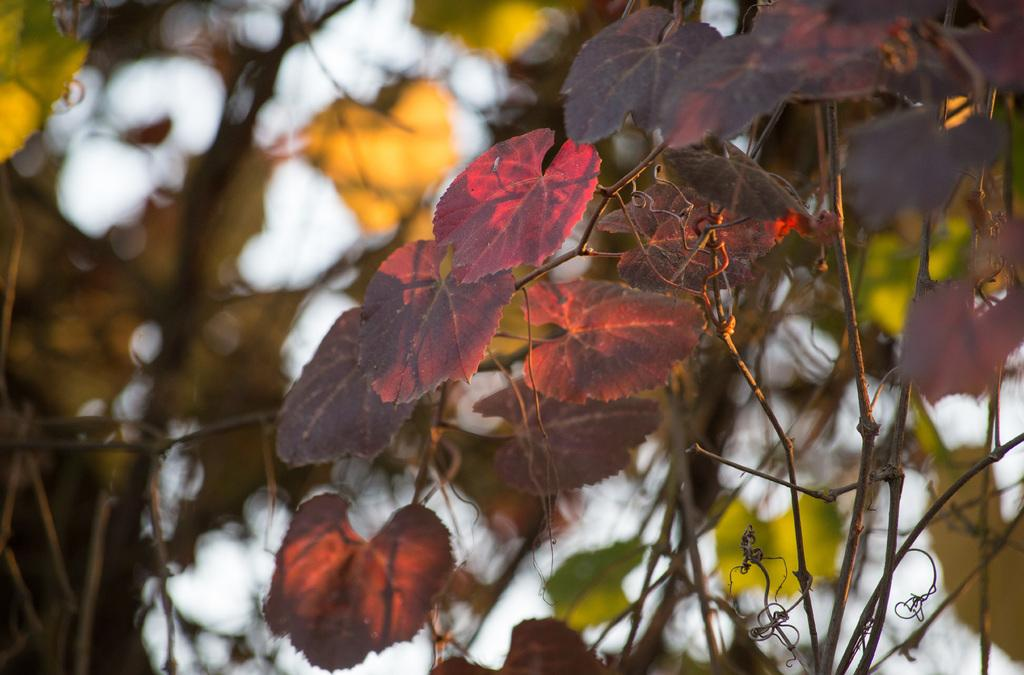What type of natural elements are present in the image? There are leaves of a tree in the image. What colors can be seen on the leaves? The leaves have various colors, including pink, black, green, and orange. What can be seen in the background of the image? There are trees and the sky visible in the background of the image. How many balloons are tied to the tree in the image? There are no balloons present in the image; it features leaves of a tree with various colors. What shape is the owner of the tree in the image? There is no owner of the tree depicted in the image, as it is a photograph of a tree and its leaves. 